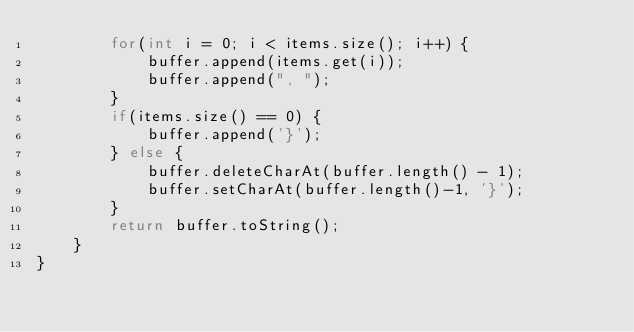<code> <loc_0><loc_0><loc_500><loc_500><_Java_>        for(int i = 0; i < items.size(); i++) {
            buffer.append(items.get(i));
            buffer.append(", ");
        }
        if(items.size() == 0) {
            buffer.append('}');
        } else {
            buffer.deleteCharAt(buffer.length() - 1);
            buffer.setCharAt(buffer.length()-1, '}');
        }
        return buffer.toString();
    }
}
</code> 